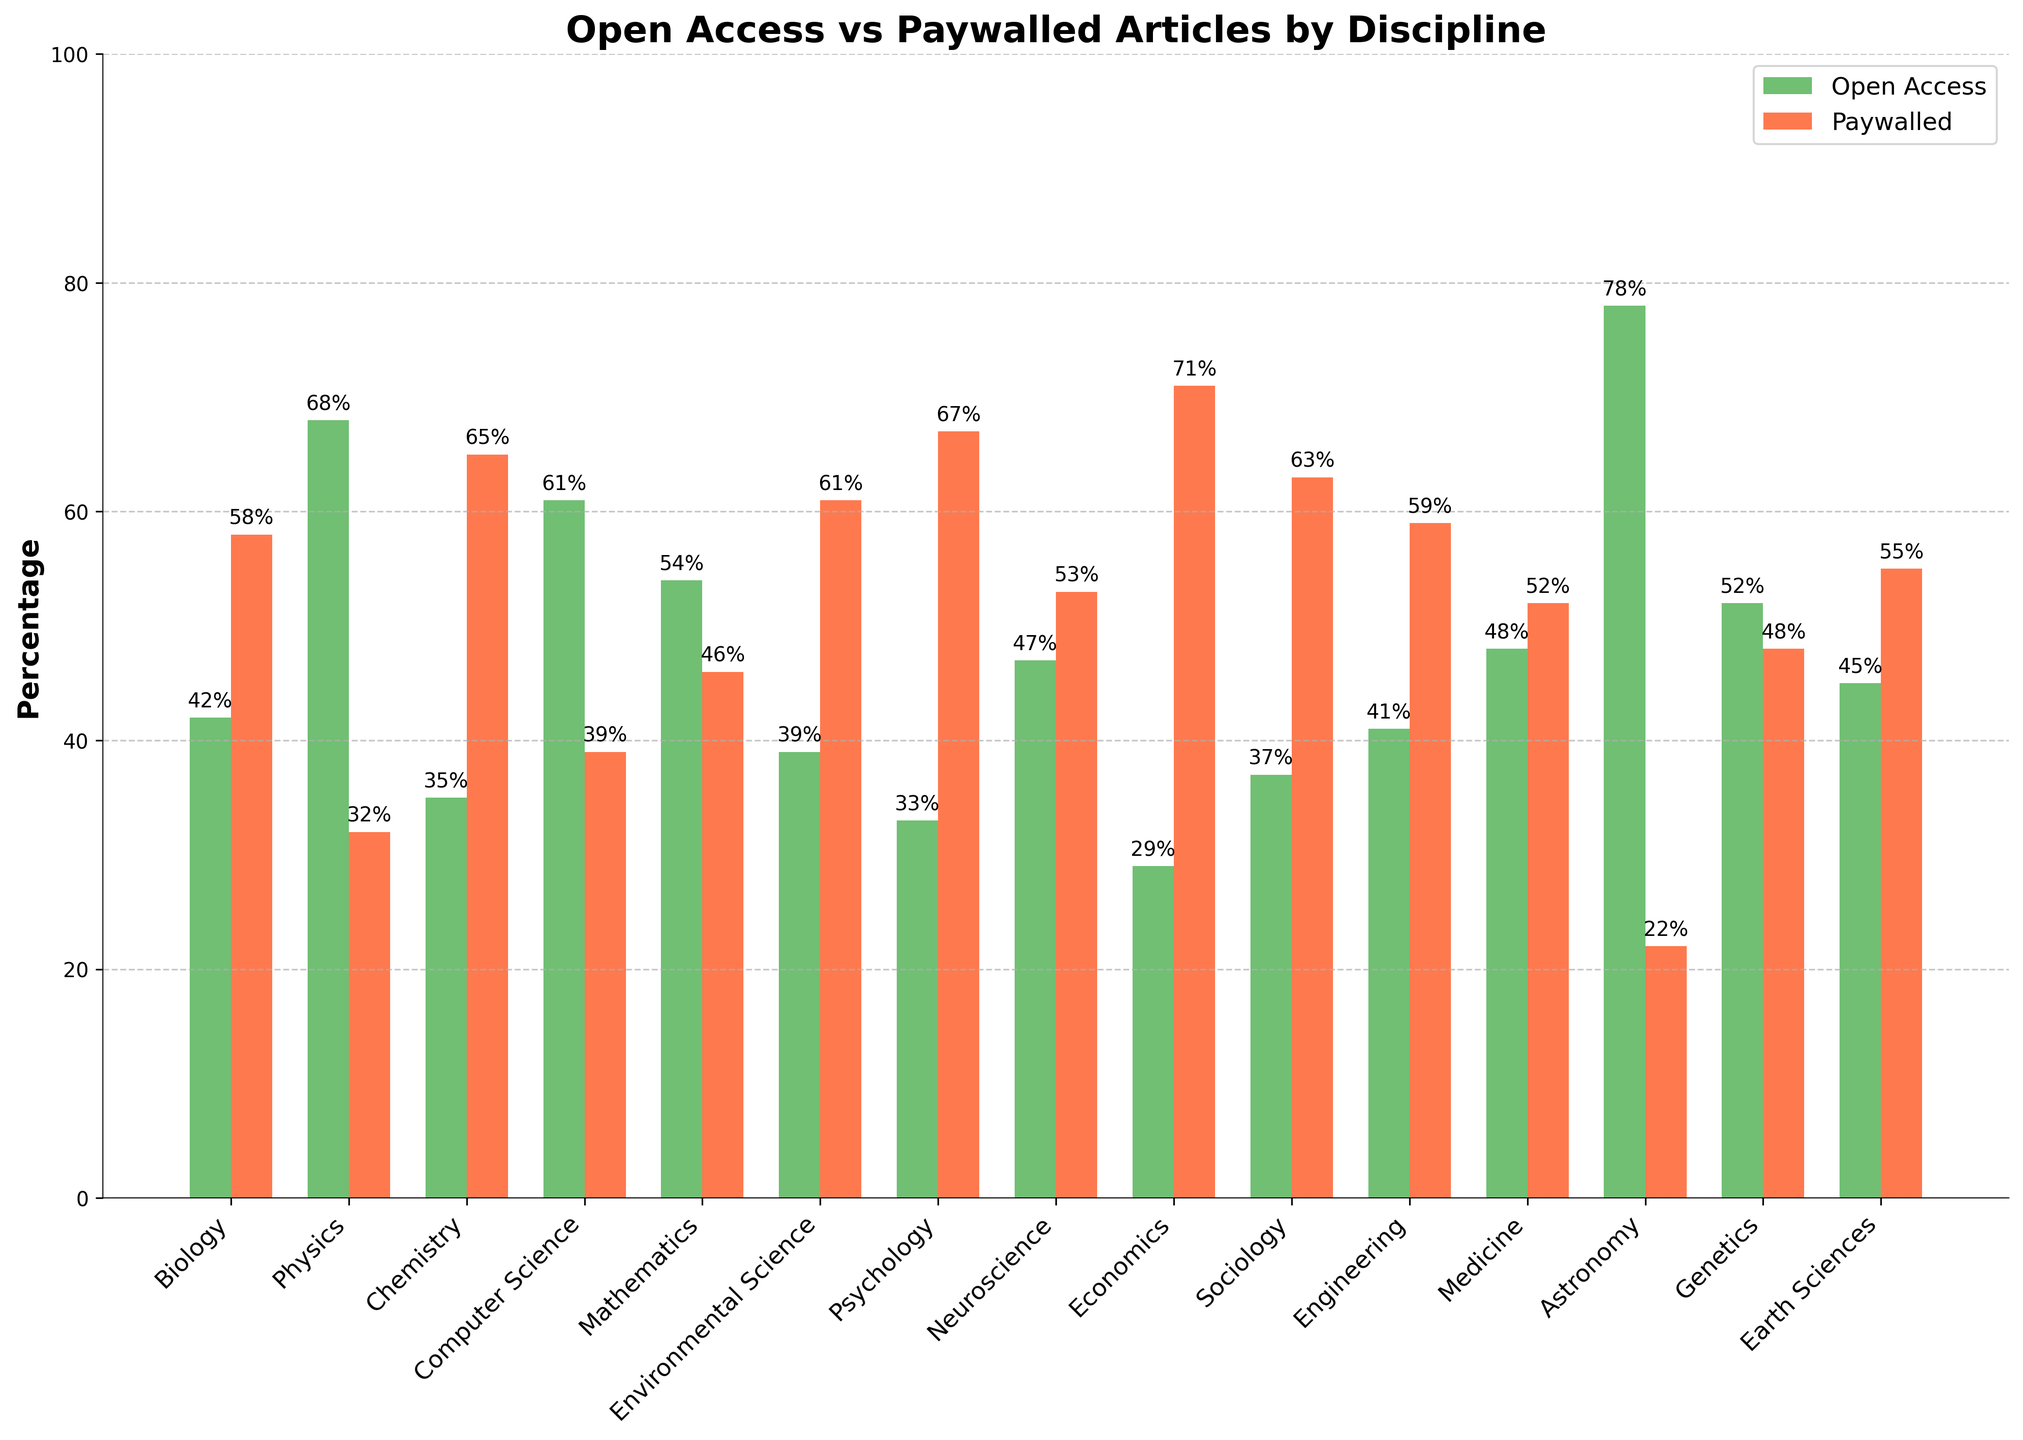Which discipline has the highest percentage of open access articles? Examine the heights of the green bars, the tallest one represents the discipline with the highest percentage of open access articles. The green bar for Astronomy is the tallest at 78%.
Answer: Astronomy Which two disciplines have the closest percentages of paywalled articles? Compare the heights of the red bars and find two that are very similar. The red bars for Neuroscience (53%) and Medicine (52%) are the closest in height.
Answer: Neuroscience and Medicine What is the combined percentage of open access articles for Biology and Chemistry? Add the open access percentages for Biology (42%) and Chemistry (35%). The combined percentage is 42 + 35.
Answer: 77% In which discipline is the difference between open access and paywalled articles the greatest? Calculate the differences between open access and paywalled percentages for each discipline and identify the largest difference. Astronomy has the largest difference (78% - 22% = 56%).
Answer: Astronomy What is the average percentage of paywalled articles across all disciplines? Sum the paywalled percentages for all disciplines and divide by the number of disciplines. The sum is 58 + 32 + 65 + 39 + 46 + 61 + 67 + 53 + 71 + 63 + 59 + 52 + 22 + 48 + 55, the number of disciplines is 15. So, the average is (817 / 15).
Answer: 54.47% Which discipline has more open access than paywalled articles? Identify disciplines where the green bar (open access) is taller than the red bar (paywalled). For Physics (68%), more articles are open access compared to paywalled (32%).
Answer: Physics What is the median percentage of open access articles across all disciplines? Arrange the open access percentages in ascending order and find the middle value(s). The sequence is 29, 33, 35, 37, 39, 41, 42, 45, 47, 48, 52, 54, 61, 68, 78. The median is the 8th value.
Answer: 45% Which disciplines have more than 50% but less than 60% open access articles? Check disciplines where the green bar is between 50% and 60%. Genetics (52%), Mathematics (54%), and Medicine (48%). Note that Medicine does not meet the criterion, so only Genetics and Mathematics qualify.
Answer: Genetics and Mathematics What is the range of open access percentages across all disciplines? Subtract the smallest open access percentage (29% in Economics) from the largest (78% in Astronomy). The range is 78 - 29.
Answer: 49 How many disciplines have at least 60% paywalled articles? Count the number of disciplines where the red bar is 60% or higher. Disciplines meeting this criterion include Chemistry (65%), Environmental Science (61%), Psychology (67%), Economics (71%), Sociology (63%).
Answer: 5 